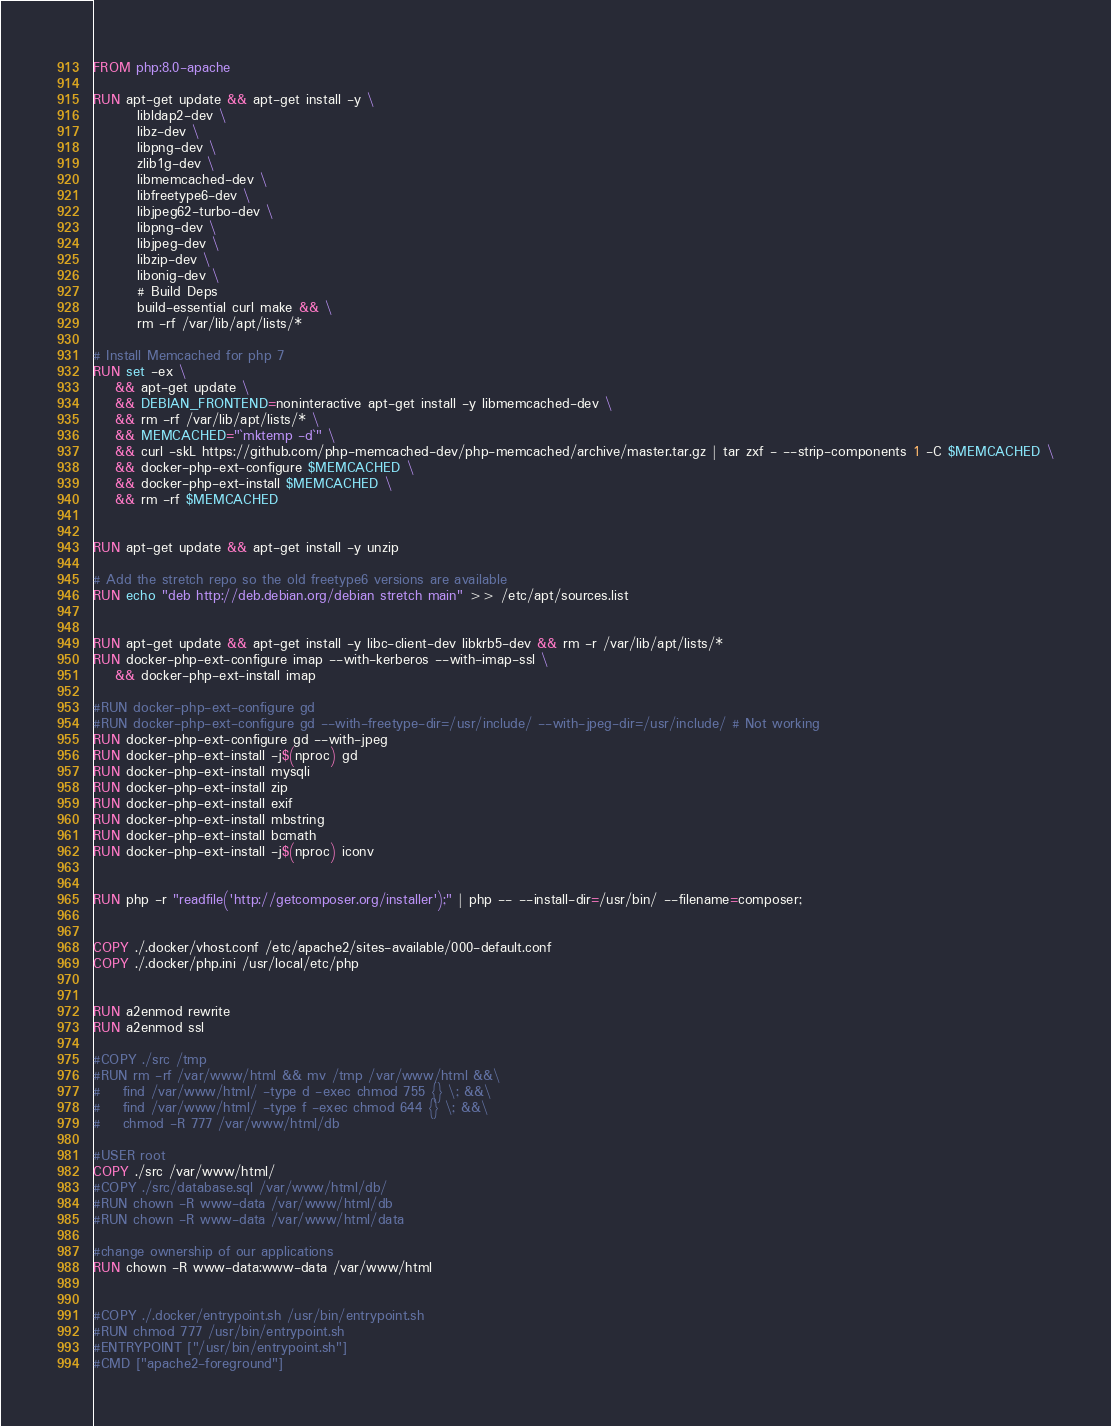Convert code to text. <code><loc_0><loc_0><loc_500><loc_500><_Dockerfile_>FROM php:8.0-apache

RUN apt-get update && apt-get install -y \
		libldap2-dev \
		libz-dev \
		libpng-dev \
		zlib1g-dev \
		libmemcached-dev \
		libfreetype6-dev \
		libjpeg62-turbo-dev \
		libpng-dev \
		libjpeg-dev \
		libzip-dev \
		libonig-dev \
		# Build Deps
		build-essential curl make && \
		rm -rf /var/lib/apt/lists/*

# Install Memcached for php 7
RUN set -ex \
    && apt-get update \
    && DEBIAN_FRONTEND=noninteractive apt-get install -y libmemcached-dev \
    && rm -rf /var/lib/apt/lists/* \
    && MEMCACHED="`mktemp -d`" \
    && curl -skL https://github.com/php-memcached-dev/php-memcached/archive/master.tar.gz | tar zxf - --strip-components 1 -C $MEMCACHED \
    && docker-php-ext-configure $MEMCACHED \
    && docker-php-ext-install $MEMCACHED \
    && rm -rf $MEMCACHED


RUN apt-get update && apt-get install -y unzip

# Add the stretch repo so the old freetype6 versions are available
RUN echo "deb http://deb.debian.org/debian stretch main" >> /etc/apt/sources.list


RUN apt-get update && apt-get install -y libc-client-dev libkrb5-dev && rm -r /var/lib/apt/lists/*
RUN docker-php-ext-configure imap --with-kerberos --with-imap-ssl \
    && docker-php-ext-install imap

#RUN docker-php-ext-configure gd
#RUN docker-php-ext-configure gd --with-freetype-dir=/usr/include/ --with-jpeg-dir=/usr/include/ # Not working
RUN docker-php-ext-configure gd --with-jpeg
RUN docker-php-ext-install -j$(nproc) gd
RUN docker-php-ext-install mysqli
RUN docker-php-ext-install zip
RUN docker-php-ext-install exif
RUN docker-php-ext-install mbstring
RUN docker-php-ext-install bcmath
RUN docker-php-ext-install -j$(nproc) iconv


RUN php -r "readfile('http://getcomposer.org/installer');" | php -- --install-dir=/usr/bin/ --filename=composer;


COPY ./.docker/vhost.conf /etc/apache2/sites-available/000-default.conf
COPY ./.docker/php.ini /usr/local/etc/php


RUN a2enmod rewrite
RUN a2enmod ssl

#COPY ./src /tmp
#RUN rm -rf /var/www/html && mv /tmp /var/www/html &&\
#    find /var/www/html/ -type d -exec chmod 755 {} \; &&\
#    find /var/www/html/ -type f -exec chmod 644 {} \; &&\
#    chmod -R 777 /var/www/html/db

#USER root
COPY ./src /var/www/html/
#COPY ./src/database.sql /var/www/html/db/
#RUN chown -R www-data /var/www/html/db
#RUN chown -R www-data /var/www/html/data

#change ownership of our applications
RUN chown -R www-data:www-data /var/www/html


#COPY ./.docker/entrypoint.sh /usr/bin/entrypoint.sh
#RUN chmod 777 /usr/bin/entrypoint.sh
#ENTRYPOINT ["/usr/bin/entrypoint.sh"]
#CMD ["apache2-foreground"]

</code> 